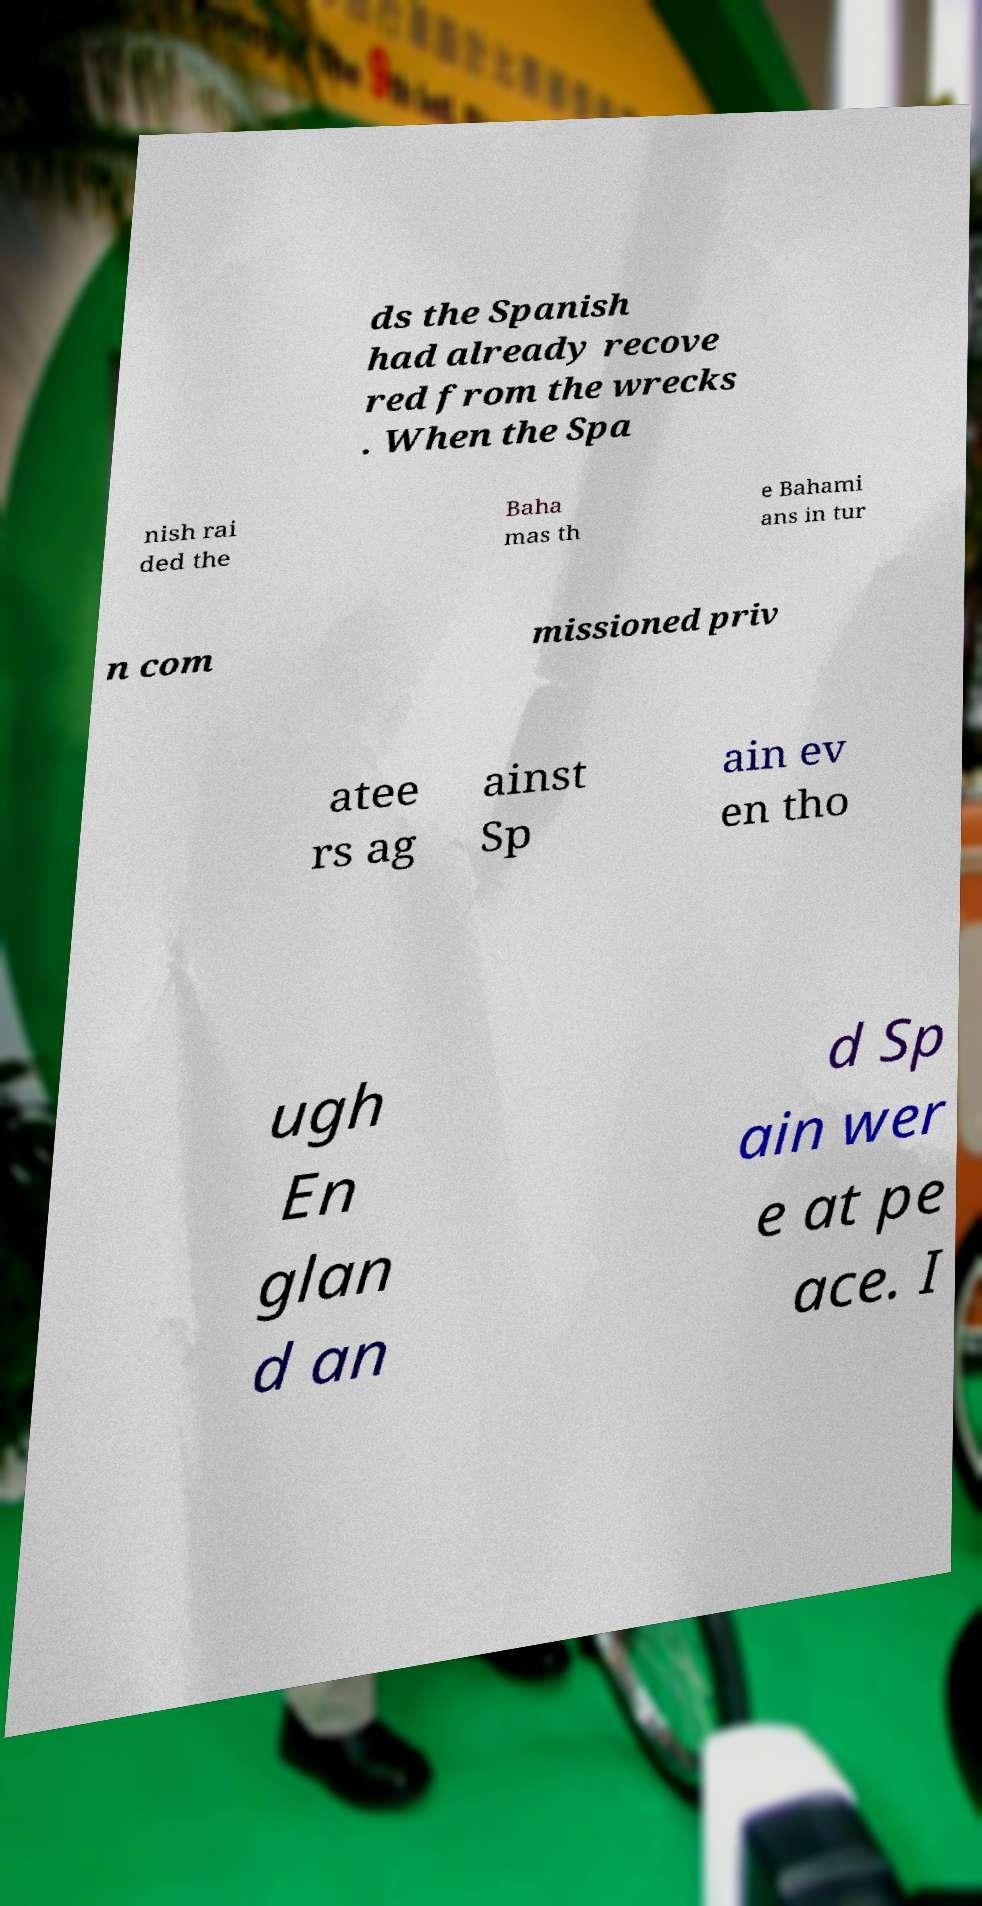I need the written content from this picture converted into text. Can you do that? ds the Spanish had already recove red from the wrecks . When the Spa nish rai ded the Baha mas th e Bahami ans in tur n com missioned priv atee rs ag ainst Sp ain ev en tho ugh En glan d an d Sp ain wer e at pe ace. I 